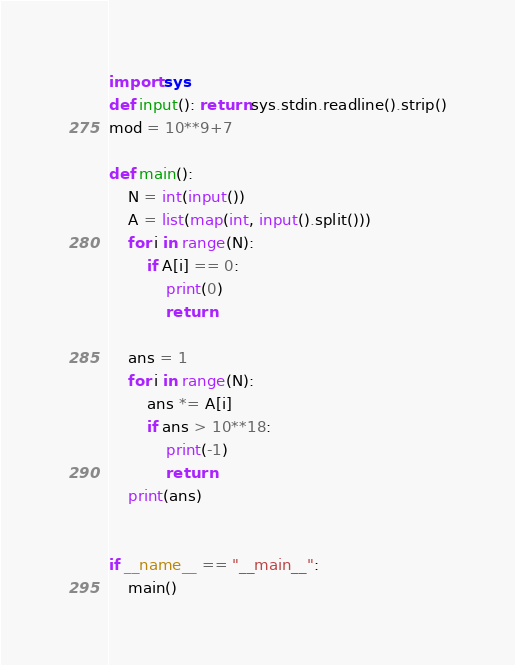<code> <loc_0><loc_0><loc_500><loc_500><_Python_>import sys
def input(): return sys.stdin.readline().strip()
mod = 10**9+7

def main():
    N = int(input())
    A = list(map(int, input().split()))
    for i in range(N):
        if A[i] == 0:
            print(0)
            return
    
    ans = 1
    for i in range(N):
        ans *= A[i]
        if ans > 10**18:
            print(-1)
            return
    print(ans)
    

if __name__ == "__main__":
    main()
</code> 